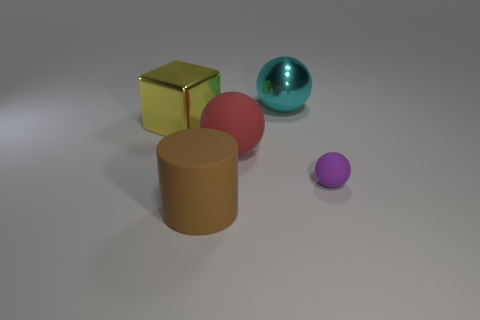Subtract all big balls. How many balls are left? 1 Add 1 yellow objects. How many objects exist? 6 Subtract all cubes. How many objects are left? 4 Subtract 0 cyan cubes. How many objects are left? 5 Subtract all big brown objects. Subtract all big metallic things. How many objects are left? 2 Add 1 large cyan things. How many large cyan things are left? 2 Add 3 big red spheres. How many big red spheres exist? 4 